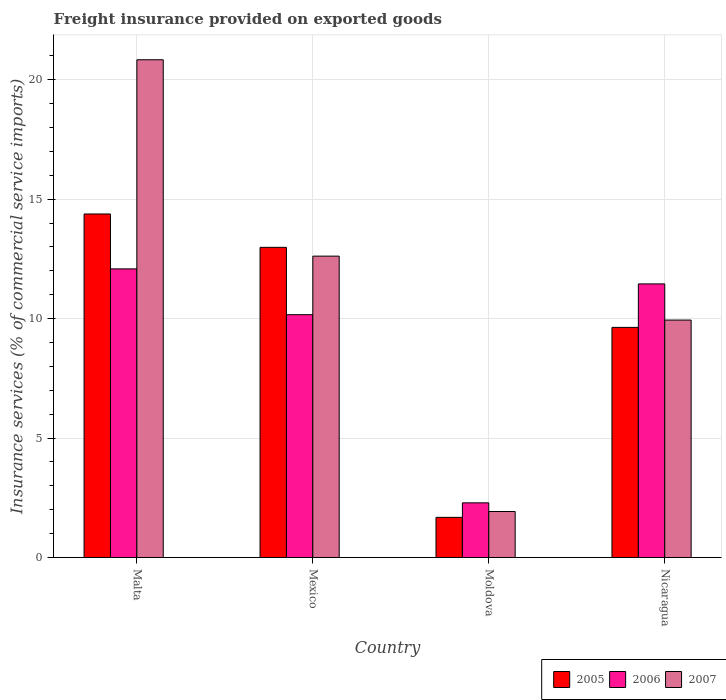How many different coloured bars are there?
Offer a very short reply. 3. Are the number of bars per tick equal to the number of legend labels?
Your answer should be compact. Yes. What is the label of the 2nd group of bars from the left?
Your answer should be very brief. Mexico. In how many cases, is the number of bars for a given country not equal to the number of legend labels?
Give a very brief answer. 0. What is the freight insurance provided on exported goods in 2007 in Nicaragua?
Provide a succinct answer. 9.94. Across all countries, what is the maximum freight insurance provided on exported goods in 2006?
Provide a short and direct response. 12.08. Across all countries, what is the minimum freight insurance provided on exported goods in 2005?
Keep it short and to the point. 1.68. In which country was the freight insurance provided on exported goods in 2005 maximum?
Keep it short and to the point. Malta. In which country was the freight insurance provided on exported goods in 2007 minimum?
Keep it short and to the point. Moldova. What is the total freight insurance provided on exported goods in 2005 in the graph?
Your response must be concise. 38.67. What is the difference between the freight insurance provided on exported goods in 2005 in Mexico and that in Moldova?
Provide a succinct answer. 11.3. What is the difference between the freight insurance provided on exported goods in 2007 in Malta and the freight insurance provided on exported goods in 2006 in Moldova?
Your answer should be very brief. 18.54. What is the average freight insurance provided on exported goods in 2005 per country?
Provide a succinct answer. 9.67. What is the difference between the freight insurance provided on exported goods of/in 2005 and freight insurance provided on exported goods of/in 2007 in Moldova?
Give a very brief answer. -0.25. In how many countries, is the freight insurance provided on exported goods in 2006 greater than 3 %?
Ensure brevity in your answer.  3. What is the ratio of the freight insurance provided on exported goods in 2005 in Malta to that in Moldova?
Offer a terse response. 8.55. What is the difference between the highest and the second highest freight insurance provided on exported goods in 2005?
Your answer should be very brief. -3.35. What is the difference between the highest and the lowest freight insurance provided on exported goods in 2005?
Your response must be concise. 12.7. Is it the case that in every country, the sum of the freight insurance provided on exported goods in 2007 and freight insurance provided on exported goods in 2005 is greater than the freight insurance provided on exported goods in 2006?
Make the answer very short. Yes. Are all the bars in the graph horizontal?
Provide a succinct answer. No. How many countries are there in the graph?
Make the answer very short. 4. What is the difference between two consecutive major ticks on the Y-axis?
Offer a very short reply. 5. Are the values on the major ticks of Y-axis written in scientific E-notation?
Ensure brevity in your answer.  No. Does the graph contain any zero values?
Make the answer very short. No. Does the graph contain grids?
Offer a very short reply. Yes. How are the legend labels stacked?
Offer a very short reply. Horizontal. What is the title of the graph?
Your answer should be very brief. Freight insurance provided on exported goods. What is the label or title of the Y-axis?
Offer a very short reply. Insurance services (% of commercial service imports). What is the Insurance services (% of commercial service imports) in 2005 in Malta?
Keep it short and to the point. 14.38. What is the Insurance services (% of commercial service imports) of 2006 in Malta?
Your response must be concise. 12.08. What is the Insurance services (% of commercial service imports) of 2007 in Malta?
Your answer should be very brief. 20.83. What is the Insurance services (% of commercial service imports) of 2005 in Mexico?
Provide a succinct answer. 12.98. What is the Insurance services (% of commercial service imports) in 2006 in Mexico?
Offer a very short reply. 10.16. What is the Insurance services (% of commercial service imports) of 2007 in Mexico?
Make the answer very short. 12.61. What is the Insurance services (% of commercial service imports) of 2005 in Moldova?
Keep it short and to the point. 1.68. What is the Insurance services (% of commercial service imports) of 2006 in Moldova?
Offer a terse response. 2.29. What is the Insurance services (% of commercial service imports) of 2007 in Moldova?
Make the answer very short. 1.93. What is the Insurance services (% of commercial service imports) in 2005 in Nicaragua?
Offer a very short reply. 9.63. What is the Insurance services (% of commercial service imports) of 2006 in Nicaragua?
Keep it short and to the point. 11.45. What is the Insurance services (% of commercial service imports) of 2007 in Nicaragua?
Ensure brevity in your answer.  9.94. Across all countries, what is the maximum Insurance services (% of commercial service imports) of 2005?
Make the answer very short. 14.38. Across all countries, what is the maximum Insurance services (% of commercial service imports) in 2006?
Provide a short and direct response. 12.08. Across all countries, what is the maximum Insurance services (% of commercial service imports) in 2007?
Make the answer very short. 20.83. Across all countries, what is the minimum Insurance services (% of commercial service imports) in 2005?
Offer a very short reply. 1.68. Across all countries, what is the minimum Insurance services (% of commercial service imports) of 2006?
Ensure brevity in your answer.  2.29. Across all countries, what is the minimum Insurance services (% of commercial service imports) in 2007?
Keep it short and to the point. 1.93. What is the total Insurance services (% of commercial service imports) in 2005 in the graph?
Provide a succinct answer. 38.67. What is the total Insurance services (% of commercial service imports) of 2006 in the graph?
Your answer should be compact. 35.98. What is the total Insurance services (% of commercial service imports) of 2007 in the graph?
Your response must be concise. 45.31. What is the difference between the Insurance services (% of commercial service imports) in 2005 in Malta and that in Mexico?
Your answer should be compact. 1.4. What is the difference between the Insurance services (% of commercial service imports) of 2006 in Malta and that in Mexico?
Your answer should be very brief. 1.92. What is the difference between the Insurance services (% of commercial service imports) of 2007 in Malta and that in Mexico?
Ensure brevity in your answer.  8.22. What is the difference between the Insurance services (% of commercial service imports) of 2005 in Malta and that in Moldova?
Keep it short and to the point. 12.7. What is the difference between the Insurance services (% of commercial service imports) in 2006 in Malta and that in Moldova?
Keep it short and to the point. 9.79. What is the difference between the Insurance services (% of commercial service imports) of 2007 in Malta and that in Moldova?
Your answer should be compact. 18.91. What is the difference between the Insurance services (% of commercial service imports) of 2005 in Malta and that in Nicaragua?
Your answer should be very brief. 4.75. What is the difference between the Insurance services (% of commercial service imports) in 2006 in Malta and that in Nicaragua?
Offer a very short reply. 0.63. What is the difference between the Insurance services (% of commercial service imports) of 2007 in Malta and that in Nicaragua?
Give a very brief answer. 10.89. What is the difference between the Insurance services (% of commercial service imports) in 2005 in Mexico and that in Moldova?
Give a very brief answer. 11.3. What is the difference between the Insurance services (% of commercial service imports) of 2006 in Mexico and that in Moldova?
Give a very brief answer. 7.87. What is the difference between the Insurance services (% of commercial service imports) of 2007 in Mexico and that in Moldova?
Ensure brevity in your answer.  10.69. What is the difference between the Insurance services (% of commercial service imports) in 2005 in Mexico and that in Nicaragua?
Your response must be concise. 3.35. What is the difference between the Insurance services (% of commercial service imports) in 2006 in Mexico and that in Nicaragua?
Keep it short and to the point. -1.29. What is the difference between the Insurance services (% of commercial service imports) in 2007 in Mexico and that in Nicaragua?
Keep it short and to the point. 2.68. What is the difference between the Insurance services (% of commercial service imports) in 2005 in Moldova and that in Nicaragua?
Offer a very short reply. -7.95. What is the difference between the Insurance services (% of commercial service imports) in 2006 in Moldova and that in Nicaragua?
Ensure brevity in your answer.  -9.16. What is the difference between the Insurance services (% of commercial service imports) in 2007 in Moldova and that in Nicaragua?
Offer a very short reply. -8.01. What is the difference between the Insurance services (% of commercial service imports) of 2005 in Malta and the Insurance services (% of commercial service imports) of 2006 in Mexico?
Provide a succinct answer. 4.22. What is the difference between the Insurance services (% of commercial service imports) of 2005 in Malta and the Insurance services (% of commercial service imports) of 2007 in Mexico?
Your answer should be very brief. 1.76. What is the difference between the Insurance services (% of commercial service imports) of 2006 in Malta and the Insurance services (% of commercial service imports) of 2007 in Mexico?
Offer a very short reply. -0.53. What is the difference between the Insurance services (% of commercial service imports) of 2005 in Malta and the Insurance services (% of commercial service imports) of 2006 in Moldova?
Your response must be concise. 12.09. What is the difference between the Insurance services (% of commercial service imports) in 2005 in Malta and the Insurance services (% of commercial service imports) in 2007 in Moldova?
Give a very brief answer. 12.45. What is the difference between the Insurance services (% of commercial service imports) of 2006 in Malta and the Insurance services (% of commercial service imports) of 2007 in Moldova?
Keep it short and to the point. 10.15. What is the difference between the Insurance services (% of commercial service imports) of 2005 in Malta and the Insurance services (% of commercial service imports) of 2006 in Nicaragua?
Give a very brief answer. 2.93. What is the difference between the Insurance services (% of commercial service imports) in 2005 in Malta and the Insurance services (% of commercial service imports) in 2007 in Nicaragua?
Ensure brevity in your answer.  4.44. What is the difference between the Insurance services (% of commercial service imports) of 2006 in Malta and the Insurance services (% of commercial service imports) of 2007 in Nicaragua?
Offer a terse response. 2.14. What is the difference between the Insurance services (% of commercial service imports) of 2005 in Mexico and the Insurance services (% of commercial service imports) of 2006 in Moldova?
Keep it short and to the point. 10.69. What is the difference between the Insurance services (% of commercial service imports) of 2005 in Mexico and the Insurance services (% of commercial service imports) of 2007 in Moldova?
Make the answer very short. 11.06. What is the difference between the Insurance services (% of commercial service imports) of 2006 in Mexico and the Insurance services (% of commercial service imports) of 2007 in Moldova?
Offer a very short reply. 8.24. What is the difference between the Insurance services (% of commercial service imports) in 2005 in Mexico and the Insurance services (% of commercial service imports) in 2006 in Nicaragua?
Your answer should be compact. 1.53. What is the difference between the Insurance services (% of commercial service imports) of 2005 in Mexico and the Insurance services (% of commercial service imports) of 2007 in Nicaragua?
Your answer should be very brief. 3.04. What is the difference between the Insurance services (% of commercial service imports) of 2006 in Mexico and the Insurance services (% of commercial service imports) of 2007 in Nicaragua?
Your answer should be compact. 0.23. What is the difference between the Insurance services (% of commercial service imports) in 2005 in Moldova and the Insurance services (% of commercial service imports) in 2006 in Nicaragua?
Provide a succinct answer. -9.77. What is the difference between the Insurance services (% of commercial service imports) of 2005 in Moldova and the Insurance services (% of commercial service imports) of 2007 in Nicaragua?
Make the answer very short. -8.26. What is the difference between the Insurance services (% of commercial service imports) in 2006 in Moldova and the Insurance services (% of commercial service imports) in 2007 in Nicaragua?
Offer a terse response. -7.65. What is the average Insurance services (% of commercial service imports) of 2005 per country?
Keep it short and to the point. 9.67. What is the average Insurance services (% of commercial service imports) of 2006 per country?
Make the answer very short. 9. What is the average Insurance services (% of commercial service imports) in 2007 per country?
Offer a terse response. 11.33. What is the difference between the Insurance services (% of commercial service imports) in 2005 and Insurance services (% of commercial service imports) in 2006 in Malta?
Your answer should be compact. 2.3. What is the difference between the Insurance services (% of commercial service imports) in 2005 and Insurance services (% of commercial service imports) in 2007 in Malta?
Make the answer very short. -6.45. What is the difference between the Insurance services (% of commercial service imports) of 2006 and Insurance services (% of commercial service imports) of 2007 in Malta?
Your response must be concise. -8.75. What is the difference between the Insurance services (% of commercial service imports) of 2005 and Insurance services (% of commercial service imports) of 2006 in Mexico?
Offer a terse response. 2.82. What is the difference between the Insurance services (% of commercial service imports) of 2005 and Insurance services (% of commercial service imports) of 2007 in Mexico?
Keep it short and to the point. 0.37. What is the difference between the Insurance services (% of commercial service imports) of 2006 and Insurance services (% of commercial service imports) of 2007 in Mexico?
Offer a terse response. -2.45. What is the difference between the Insurance services (% of commercial service imports) in 2005 and Insurance services (% of commercial service imports) in 2006 in Moldova?
Keep it short and to the point. -0.61. What is the difference between the Insurance services (% of commercial service imports) in 2005 and Insurance services (% of commercial service imports) in 2007 in Moldova?
Give a very brief answer. -0.25. What is the difference between the Insurance services (% of commercial service imports) in 2006 and Insurance services (% of commercial service imports) in 2007 in Moldova?
Make the answer very short. 0.36. What is the difference between the Insurance services (% of commercial service imports) of 2005 and Insurance services (% of commercial service imports) of 2006 in Nicaragua?
Give a very brief answer. -1.82. What is the difference between the Insurance services (% of commercial service imports) of 2005 and Insurance services (% of commercial service imports) of 2007 in Nicaragua?
Provide a short and direct response. -0.31. What is the difference between the Insurance services (% of commercial service imports) of 2006 and Insurance services (% of commercial service imports) of 2007 in Nicaragua?
Provide a succinct answer. 1.51. What is the ratio of the Insurance services (% of commercial service imports) of 2005 in Malta to that in Mexico?
Provide a short and direct response. 1.11. What is the ratio of the Insurance services (% of commercial service imports) of 2006 in Malta to that in Mexico?
Make the answer very short. 1.19. What is the ratio of the Insurance services (% of commercial service imports) of 2007 in Malta to that in Mexico?
Offer a terse response. 1.65. What is the ratio of the Insurance services (% of commercial service imports) of 2005 in Malta to that in Moldova?
Your response must be concise. 8.55. What is the ratio of the Insurance services (% of commercial service imports) of 2006 in Malta to that in Moldova?
Provide a short and direct response. 5.28. What is the ratio of the Insurance services (% of commercial service imports) of 2007 in Malta to that in Moldova?
Make the answer very short. 10.82. What is the ratio of the Insurance services (% of commercial service imports) in 2005 in Malta to that in Nicaragua?
Offer a very short reply. 1.49. What is the ratio of the Insurance services (% of commercial service imports) of 2006 in Malta to that in Nicaragua?
Provide a short and direct response. 1.05. What is the ratio of the Insurance services (% of commercial service imports) in 2007 in Malta to that in Nicaragua?
Give a very brief answer. 2.1. What is the ratio of the Insurance services (% of commercial service imports) of 2005 in Mexico to that in Moldova?
Your response must be concise. 7.72. What is the ratio of the Insurance services (% of commercial service imports) in 2006 in Mexico to that in Moldova?
Your answer should be very brief. 4.44. What is the ratio of the Insurance services (% of commercial service imports) in 2007 in Mexico to that in Moldova?
Provide a short and direct response. 6.55. What is the ratio of the Insurance services (% of commercial service imports) in 2005 in Mexico to that in Nicaragua?
Your answer should be very brief. 1.35. What is the ratio of the Insurance services (% of commercial service imports) in 2006 in Mexico to that in Nicaragua?
Offer a terse response. 0.89. What is the ratio of the Insurance services (% of commercial service imports) in 2007 in Mexico to that in Nicaragua?
Make the answer very short. 1.27. What is the ratio of the Insurance services (% of commercial service imports) of 2005 in Moldova to that in Nicaragua?
Your answer should be compact. 0.17. What is the ratio of the Insurance services (% of commercial service imports) of 2006 in Moldova to that in Nicaragua?
Offer a very short reply. 0.2. What is the ratio of the Insurance services (% of commercial service imports) of 2007 in Moldova to that in Nicaragua?
Offer a very short reply. 0.19. What is the difference between the highest and the second highest Insurance services (% of commercial service imports) in 2005?
Ensure brevity in your answer.  1.4. What is the difference between the highest and the second highest Insurance services (% of commercial service imports) in 2006?
Ensure brevity in your answer.  0.63. What is the difference between the highest and the second highest Insurance services (% of commercial service imports) of 2007?
Ensure brevity in your answer.  8.22. What is the difference between the highest and the lowest Insurance services (% of commercial service imports) of 2005?
Ensure brevity in your answer.  12.7. What is the difference between the highest and the lowest Insurance services (% of commercial service imports) of 2006?
Offer a terse response. 9.79. What is the difference between the highest and the lowest Insurance services (% of commercial service imports) in 2007?
Keep it short and to the point. 18.91. 